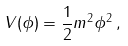<formula> <loc_0><loc_0><loc_500><loc_500>V ( \phi ) = \frac { 1 } { 2 } m ^ { 2 } \phi ^ { 2 } \, ,</formula> 